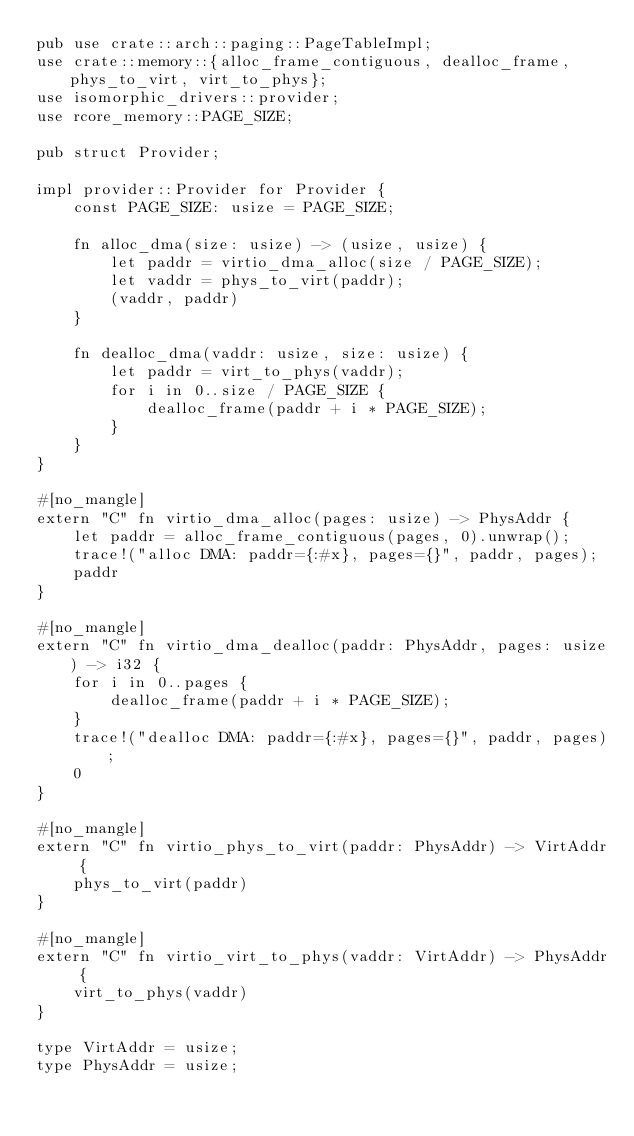<code> <loc_0><loc_0><loc_500><loc_500><_Rust_>pub use crate::arch::paging::PageTableImpl;
use crate::memory::{alloc_frame_contiguous, dealloc_frame, phys_to_virt, virt_to_phys};
use isomorphic_drivers::provider;
use rcore_memory::PAGE_SIZE;

pub struct Provider;

impl provider::Provider for Provider {
    const PAGE_SIZE: usize = PAGE_SIZE;

    fn alloc_dma(size: usize) -> (usize, usize) {
        let paddr = virtio_dma_alloc(size / PAGE_SIZE);
        let vaddr = phys_to_virt(paddr);
        (vaddr, paddr)
    }

    fn dealloc_dma(vaddr: usize, size: usize) {
        let paddr = virt_to_phys(vaddr);
        for i in 0..size / PAGE_SIZE {
            dealloc_frame(paddr + i * PAGE_SIZE);
        }
    }
}

#[no_mangle]
extern "C" fn virtio_dma_alloc(pages: usize) -> PhysAddr {
    let paddr = alloc_frame_contiguous(pages, 0).unwrap();
    trace!("alloc DMA: paddr={:#x}, pages={}", paddr, pages);
    paddr
}

#[no_mangle]
extern "C" fn virtio_dma_dealloc(paddr: PhysAddr, pages: usize) -> i32 {
    for i in 0..pages {
        dealloc_frame(paddr + i * PAGE_SIZE);
    }
    trace!("dealloc DMA: paddr={:#x}, pages={}", paddr, pages);
    0
}

#[no_mangle]
extern "C" fn virtio_phys_to_virt(paddr: PhysAddr) -> VirtAddr {
    phys_to_virt(paddr)
}

#[no_mangle]
extern "C" fn virtio_virt_to_phys(vaddr: VirtAddr) -> PhysAddr {
    virt_to_phys(vaddr)
}

type VirtAddr = usize;
type PhysAddr = usize;
</code> 